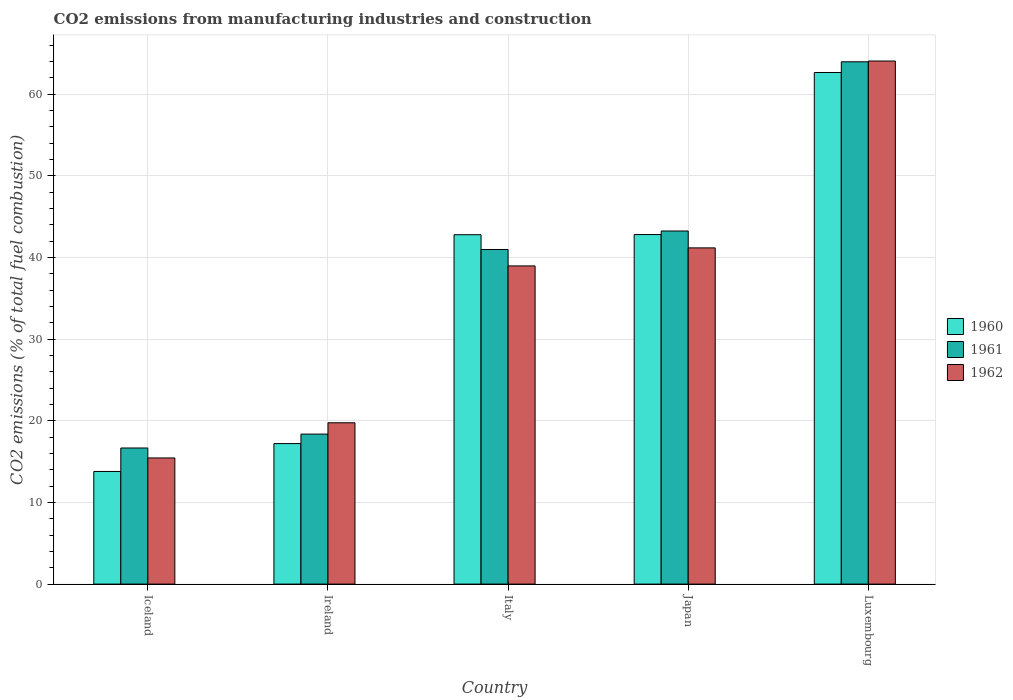How many different coloured bars are there?
Your answer should be very brief. 3. Are the number of bars per tick equal to the number of legend labels?
Give a very brief answer. Yes. How many bars are there on the 5th tick from the left?
Make the answer very short. 3. What is the label of the 4th group of bars from the left?
Offer a terse response. Japan. What is the amount of CO2 emitted in 1961 in Ireland?
Provide a short and direct response. 18.37. Across all countries, what is the maximum amount of CO2 emitted in 1962?
Keep it short and to the point. 64.05. Across all countries, what is the minimum amount of CO2 emitted in 1960?
Provide a succinct answer. 13.79. In which country was the amount of CO2 emitted in 1960 maximum?
Your answer should be compact. Luxembourg. What is the total amount of CO2 emitted in 1960 in the graph?
Make the answer very short. 179.23. What is the difference between the amount of CO2 emitted in 1960 in Iceland and that in Luxembourg?
Provide a short and direct response. -48.85. What is the difference between the amount of CO2 emitted in 1961 in Italy and the amount of CO2 emitted in 1962 in Iceland?
Provide a succinct answer. 25.53. What is the average amount of CO2 emitted in 1962 per country?
Your answer should be very brief. 35.88. What is the difference between the amount of CO2 emitted of/in 1961 and amount of CO2 emitted of/in 1960 in Japan?
Ensure brevity in your answer.  0.44. In how many countries, is the amount of CO2 emitted in 1960 greater than 24 %?
Your answer should be very brief. 3. What is the ratio of the amount of CO2 emitted in 1962 in Ireland to that in Italy?
Make the answer very short. 0.51. Is the difference between the amount of CO2 emitted in 1961 in Iceland and Luxembourg greater than the difference between the amount of CO2 emitted in 1960 in Iceland and Luxembourg?
Ensure brevity in your answer.  Yes. What is the difference between the highest and the second highest amount of CO2 emitted in 1961?
Ensure brevity in your answer.  -2.26. What is the difference between the highest and the lowest amount of CO2 emitted in 1962?
Provide a succinct answer. 48.6. In how many countries, is the amount of CO2 emitted in 1962 greater than the average amount of CO2 emitted in 1962 taken over all countries?
Ensure brevity in your answer.  3. Is the sum of the amount of CO2 emitted in 1962 in Ireland and Japan greater than the maximum amount of CO2 emitted in 1961 across all countries?
Provide a short and direct response. No. What does the 2nd bar from the left in Ireland represents?
Offer a terse response. 1961. What does the 2nd bar from the right in Luxembourg represents?
Provide a succinct answer. 1961. How many bars are there?
Your answer should be compact. 15. What is the difference between two consecutive major ticks on the Y-axis?
Provide a short and direct response. 10. Does the graph contain any zero values?
Ensure brevity in your answer.  No. Does the graph contain grids?
Make the answer very short. Yes. Where does the legend appear in the graph?
Offer a very short reply. Center right. How many legend labels are there?
Offer a very short reply. 3. How are the legend labels stacked?
Give a very brief answer. Vertical. What is the title of the graph?
Offer a terse response. CO2 emissions from manufacturing industries and construction. What is the label or title of the Y-axis?
Offer a terse response. CO2 emissions (% of total fuel combustion). What is the CO2 emissions (% of total fuel combustion) in 1960 in Iceland?
Your response must be concise. 13.79. What is the CO2 emissions (% of total fuel combustion) of 1961 in Iceland?
Your answer should be very brief. 16.67. What is the CO2 emissions (% of total fuel combustion) in 1962 in Iceland?
Your answer should be compact. 15.45. What is the CO2 emissions (% of total fuel combustion) in 1960 in Ireland?
Provide a succinct answer. 17.21. What is the CO2 emissions (% of total fuel combustion) of 1961 in Ireland?
Your answer should be compact. 18.37. What is the CO2 emissions (% of total fuel combustion) of 1962 in Ireland?
Ensure brevity in your answer.  19.75. What is the CO2 emissions (% of total fuel combustion) in 1960 in Italy?
Provide a short and direct response. 42.78. What is the CO2 emissions (% of total fuel combustion) of 1961 in Italy?
Ensure brevity in your answer.  40.97. What is the CO2 emissions (% of total fuel combustion) in 1962 in Italy?
Provide a short and direct response. 38.96. What is the CO2 emissions (% of total fuel combustion) of 1960 in Japan?
Make the answer very short. 42.8. What is the CO2 emissions (% of total fuel combustion) in 1961 in Japan?
Give a very brief answer. 43.24. What is the CO2 emissions (% of total fuel combustion) of 1962 in Japan?
Offer a very short reply. 41.17. What is the CO2 emissions (% of total fuel combustion) in 1960 in Luxembourg?
Give a very brief answer. 62.65. What is the CO2 emissions (% of total fuel combustion) of 1961 in Luxembourg?
Keep it short and to the point. 63.95. What is the CO2 emissions (% of total fuel combustion) in 1962 in Luxembourg?
Ensure brevity in your answer.  64.05. Across all countries, what is the maximum CO2 emissions (% of total fuel combustion) in 1960?
Give a very brief answer. 62.65. Across all countries, what is the maximum CO2 emissions (% of total fuel combustion) of 1961?
Provide a succinct answer. 63.95. Across all countries, what is the maximum CO2 emissions (% of total fuel combustion) of 1962?
Offer a terse response. 64.05. Across all countries, what is the minimum CO2 emissions (% of total fuel combustion) in 1960?
Your answer should be compact. 13.79. Across all countries, what is the minimum CO2 emissions (% of total fuel combustion) in 1961?
Make the answer very short. 16.67. Across all countries, what is the minimum CO2 emissions (% of total fuel combustion) in 1962?
Your answer should be compact. 15.45. What is the total CO2 emissions (% of total fuel combustion) of 1960 in the graph?
Your answer should be compact. 179.23. What is the total CO2 emissions (% of total fuel combustion) of 1961 in the graph?
Keep it short and to the point. 183.2. What is the total CO2 emissions (% of total fuel combustion) in 1962 in the graph?
Your answer should be very brief. 179.38. What is the difference between the CO2 emissions (% of total fuel combustion) in 1960 in Iceland and that in Ireland?
Your response must be concise. -3.41. What is the difference between the CO2 emissions (% of total fuel combustion) of 1961 in Iceland and that in Ireland?
Provide a succinct answer. -1.7. What is the difference between the CO2 emissions (% of total fuel combustion) in 1962 in Iceland and that in Ireland?
Give a very brief answer. -4.31. What is the difference between the CO2 emissions (% of total fuel combustion) in 1960 in Iceland and that in Italy?
Give a very brief answer. -28.99. What is the difference between the CO2 emissions (% of total fuel combustion) in 1961 in Iceland and that in Italy?
Make the answer very short. -24.31. What is the difference between the CO2 emissions (% of total fuel combustion) in 1962 in Iceland and that in Italy?
Provide a short and direct response. -23.51. What is the difference between the CO2 emissions (% of total fuel combustion) of 1960 in Iceland and that in Japan?
Provide a short and direct response. -29.01. What is the difference between the CO2 emissions (% of total fuel combustion) of 1961 in Iceland and that in Japan?
Offer a terse response. -26.57. What is the difference between the CO2 emissions (% of total fuel combustion) of 1962 in Iceland and that in Japan?
Your answer should be compact. -25.72. What is the difference between the CO2 emissions (% of total fuel combustion) in 1960 in Iceland and that in Luxembourg?
Your answer should be compact. -48.85. What is the difference between the CO2 emissions (% of total fuel combustion) of 1961 in Iceland and that in Luxembourg?
Your answer should be compact. -47.29. What is the difference between the CO2 emissions (% of total fuel combustion) of 1962 in Iceland and that in Luxembourg?
Provide a succinct answer. -48.6. What is the difference between the CO2 emissions (% of total fuel combustion) in 1960 in Ireland and that in Italy?
Offer a terse response. -25.57. What is the difference between the CO2 emissions (% of total fuel combustion) of 1961 in Ireland and that in Italy?
Your answer should be compact. -22.61. What is the difference between the CO2 emissions (% of total fuel combustion) of 1962 in Ireland and that in Italy?
Provide a short and direct response. -19.21. What is the difference between the CO2 emissions (% of total fuel combustion) in 1960 in Ireland and that in Japan?
Provide a short and direct response. -25.6. What is the difference between the CO2 emissions (% of total fuel combustion) in 1961 in Ireland and that in Japan?
Provide a short and direct response. -24.87. What is the difference between the CO2 emissions (% of total fuel combustion) of 1962 in Ireland and that in Japan?
Your answer should be very brief. -21.42. What is the difference between the CO2 emissions (% of total fuel combustion) of 1960 in Ireland and that in Luxembourg?
Provide a short and direct response. -45.44. What is the difference between the CO2 emissions (% of total fuel combustion) in 1961 in Ireland and that in Luxembourg?
Provide a short and direct response. -45.59. What is the difference between the CO2 emissions (% of total fuel combustion) of 1962 in Ireland and that in Luxembourg?
Provide a short and direct response. -44.3. What is the difference between the CO2 emissions (% of total fuel combustion) in 1960 in Italy and that in Japan?
Your answer should be very brief. -0.02. What is the difference between the CO2 emissions (% of total fuel combustion) in 1961 in Italy and that in Japan?
Provide a succinct answer. -2.26. What is the difference between the CO2 emissions (% of total fuel combustion) in 1962 in Italy and that in Japan?
Give a very brief answer. -2.21. What is the difference between the CO2 emissions (% of total fuel combustion) of 1960 in Italy and that in Luxembourg?
Provide a succinct answer. -19.86. What is the difference between the CO2 emissions (% of total fuel combustion) in 1961 in Italy and that in Luxembourg?
Ensure brevity in your answer.  -22.98. What is the difference between the CO2 emissions (% of total fuel combustion) in 1962 in Italy and that in Luxembourg?
Offer a terse response. -25.09. What is the difference between the CO2 emissions (% of total fuel combustion) of 1960 in Japan and that in Luxembourg?
Provide a short and direct response. -19.84. What is the difference between the CO2 emissions (% of total fuel combustion) in 1961 in Japan and that in Luxembourg?
Provide a short and direct response. -20.72. What is the difference between the CO2 emissions (% of total fuel combustion) in 1962 in Japan and that in Luxembourg?
Your response must be concise. -22.88. What is the difference between the CO2 emissions (% of total fuel combustion) of 1960 in Iceland and the CO2 emissions (% of total fuel combustion) of 1961 in Ireland?
Make the answer very short. -4.57. What is the difference between the CO2 emissions (% of total fuel combustion) of 1960 in Iceland and the CO2 emissions (% of total fuel combustion) of 1962 in Ireland?
Make the answer very short. -5.96. What is the difference between the CO2 emissions (% of total fuel combustion) in 1961 in Iceland and the CO2 emissions (% of total fuel combustion) in 1962 in Ireland?
Provide a succinct answer. -3.09. What is the difference between the CO2 emissions (% of total fuel combustion) of 1960 in Iceland and the CO2 emissions (% of total fuel combustion) of 1961 in Italy?
Provide a succinct answer. -27.18. What is the difference between the CO2 emissions (% of total fuel combustion) of 1960 in Iceland and the CO2 emissions (% of total fuel combustion) of 1962 in Italy?
Make the answer very short. -25.17. What is the difference between the CO2 emissions (% of total fuel combustion) in 1961 in Iceland and the CO2 emissions (% of total fuel combustion) in 1962 in Italy?
Your answer should be very brief. -22.29. What is the difference between the CO2 emissions (% of total fuel combustion) in 1960 in Iceland and the CO2 emissions (% of total fuel combustion) in 1961 in Japan?
Make the answer very short. -29.44. What is the difference between the CO2 emissions (% of total fuel combustion) of 1960 in Iceland and the CO2 emissions (% of total fuel combustion) of 1962 in Japan?
Provide a succinct answer. -27.38. What is the difference between the CO2 emissions (% of total fuel combustion) of 1961 in Iceland and the CO2 emissions (% of total fuel combustion) of 1962 in Japan?
Make the answer very short. -24.5. What is the difference between the CO2 emissions (% of total fuel combustion) in 1960 in Iceland and the CO2 emissions (% of total fuel combustion) in 1961 in Luxembourg?
Offer a very short reply. -50.16. What is the difference between the CO2 emissions (% of total fuel combustion) in 1960 in Iceland and the CO2 emissions (% of total fuel combustion) in 1962 in Luxembourg?
Your response must be concise. -50.26. What is the difference between the CO2 emissions (% of total fuel combustion) of 1961 in Iceland and the CO2 emissions (% of total fuel combustion) of 1962 in Luxembourg?
Make the answer very short. -47.38. What is the difference between the CO2 emissions (% of total fuel combustion) of 1960 in Ireland and the CO2 emissions (% of total fuel combustion) of 1961 in Italy?
Offer a very short reply. -23.77. What is the difference between the CO2 emissions (% of total fuel combustion) of 1960 in Ireland and the CO2 emissions (% of total fuel combustion) of 1962 in Italy?
Your answer should be compact. -21.75. What is the difference between the CO2 emissions (% of total fuel combustion) in 1961 in Ireland and the CO2 emissions (% of total fuel combustion) in 1962 in Italy?
Provide a short and direct response. -20.59. What is the difference between the CO2 emissions (% of total fuel combustion) of 1960 in Ireland and the CO2 emissions (% of total fuel combustion) of 1961 in Japan?
Ensure brevity in your answer.  -26.03. What is the difference between the CO2 emissions (% of total fuel combustion) in 1960 in Ireland and the CO2 emissions (% of total fuel combustion) in 1962 in Japan?
Offer a very short reply. -23.96. What is the difference between the CO2 emissions (% of total fuel combustion) of 1961 in Ireland and the CO2 emissions (% of total fuel combustion) of 1962 in Japan?
Provide a short and direct response. -22.8. What is the difference between the CO2 emissions (% of total fuel combustion) of 1960 in Ireland and the CO2 emissions (% of total fuel combustion) of 1961 in Luxembourg?
Ensure brevity in your answer.  -46.75. What is the difference between the CO2 emissions (% of total fuel combustion) of 1960 in Ireland and the CO2 emissions (% of total fuel combustion) of 1962 in Luxembourg?
Ensure brevity in your answer.  -46.84. What is the difference between the CO2 emissions (% of total fuel combustion) in 1961 in Ireland and the CO2 emissions (% of total fuel combustion) in 1962 in Luxembourg?
Keep it short and to the point. -45.68. What is the difference between the CO2 emissions (% of total fuel combustion) in 1960 in Italy and the CO2 emissions (% of total fuel combustion) in 1961 in Japan?
Keep it short and to the point. -0.46. What is the difference between the CO2 emissions (% of total fuel combustion) of 1960 in Italy and the CO2 emissions (% of total fuel combustion) of 1962 in Japan?
Your answer should be compact. 1.61. What is the difference between the CO2 emissions (% of total fuel combustion) of 1961 in Italy and the CO2 emissions (% of total fuel combustion) of 1962 in Japan?
Ensure brevity in your answer.  -0.2. What is the difference between the CO2 emissions (% of total fuel combustion) of 1960 in Italy and the CO2 emissions (% of total fuel combustion) of 1961 in Luxembourg?
Offer a very short reply. -21.17. What is the difference between the CO2 emissions (% of total fuel combustion) in 1960 in Italy and the CO2 emissions (% of total fuel combustion) in 1962 in Luxembourg?
Offer a terse response. -21.27. What is the difference between the CO2 emissions (% of total fuel combustion) of 1961 in Italy and the CO2 emissions (% of total fuel combustion) of 1962 in Luxembourg?
Your answer should be compact. -23.08. What is the difference between the CO2 emissions (% of total fuel combustion) in 1960 in Japan and the CO2 emissions (% of total fuel combustion) in 1961 in Luxembourg?
Offer a terse response. -21.15. What is the difference between the CO2 emissions (% of total fuel combustion) of 1960 in Japan and the CO2 emissions (% of total fuel combustion) of 1962 in Luxembourg?
Offer a very short reply. -21.25. What is the difference between the CO2 emissions (% of total fuel combustion) in 1961 in Japan and the CO2 emissions (% of total fuel combustion) in 1962 in Luxembourg?
Your response must be concise. -20.81. What is the average CO2 emissions (% of total fuel combustion) of 1960 per country?
Give a very brief answer. 35.85. What is the average CO2 emissions (% of total fuel combustion) in 1961 per country?
Keep it short and to the point. 36.64. What is the average CO2 emissions (% of total fuel combustion) of 1962 per country?
Give a very brief answer. 35.88. What is the difference between the CO2 emissions (% of total fuel combustion) in 1960 and CO2 emissions (% of total fuel combustion) in 1961 in Iceland?
Offer a very short reply. -2.87. What is the difference between the CO2 emissions (% of total fuel combustion) in 1960 and CO2 emissions (% of total fuel combustion) in 1962 in Iceland?
Make the answer very short. -1.65. What is the difference between the CO2 emissions (% of total fuel combustion) in 1961 and CO2 emissions (% of total fuel combustion) in 1962 in Iceland?
Your response must be concise. 1.22. What is the difference between the CO2 emissions (% of total fuel combustion) of 1960 and CO2 emissions (% of total fuel combustion) of 1961 in Ireland?
Offer a very short reply. -1.16. What is the difference between the CO2 emissions (% of total fuel combustion) in 1960 and CO2 emissions (% of total fuel combustion) in 1962 in Ireland?
Provide a succinct answer. -2.55. What is the difference between the CO2 emissions (% of total fuel combustion) in 1961 and CO2 emissions (% of total fuel combustion) in 1962 in Ireland?
Your answer should be very brief. -1.39. What is the difference between the CO2 emissions (% of total fuel combustion) in 1960 and CO2 emissions (% of total fuel combustion) in 1961 in Italy?
Give a very brief answer. 1.81. What is the difference between the CO2 emissions (% of total fuel combustion) of 1960 and CO2 emissions (% of total fuel combustion) of 1962 in Italy?
Give a very brief answer. 3.82. What is the difference between the CO2 emissions (% of total fuel combustion) in 1961 and CO2 emissions (% of total fuel combustion) in 1962 in Italy?
Your response must be concise. 2.01. What is the difference between the CO2 emissions (% of total fuel combustion) in 1960 and CO2 emissions (% of total fuel combustion) in 1961 in Japan?
Keep it short and to the point. -0.44. What is the difference between the CO2 emissions (% of total fuel combustion) of 1960 and CO2 emissions (% of total fuel combustion) of 1962 in Japan?
Your answer should be very brief. 1.63. What is the difference between the CO2 emissions (% of total fuel combustion) of 1961 and CO2 emissions (% of total fuel combustion) of 1962 in Japan?
Your answer should be very brief. 2.07. What is the difference between the CO2 emissions (% of total fuel combustion) in 1960 and CO2 emissions (% of total fuel combustion) in 1961 in Luxembourg?
Provide a succinct answer. -1.31. What is the difference between the CO2 emissions (% of total fuel combustion) in 1960 and CO2 emissions (% of total fuel combustion) in 1962 in Luxembourg?
Make the answer very short. -1.4. What is the difference between the CO2 emissions (% of total fuel combustion) in 1961 and CO2 emissions (% of total fuel combustion) in 1962 in Luxembourg?
Ensure brevity in your answer.  -0.1. What is the ratio of the CO2 emissions (% of total fuel combustion) in 1960 in Iceland to that in Ireland?
Offer a very short reply. 0.8. What is the ratio of the CO2 emissions (% of total fuel combustion) of 1961 in Iceland to that in Ireland?
Give a very brief answer. 0.91. What is the ratio of the CO2 emissions (% of total fuel combustion) in 1962 in Iceland to that in Ireland?
Your answer should be compact. 0.78. What is the ratio of the CO2 emissions (% of total fuel combustion) in 1960 in Iceland to that in Italy?
Offer a terse response. 0.32. What is the ratio of the CO2 emissions (% of total fuel combustion) of 1961 in Iceland to that in Italy?
Provide a succinct answer. 0.41. What is the ratio of the CO2 emissions (% of total fuel combustion) in 1962 in Iceland to that in Italy?
Give a very brief answer. 0.4. What is the ratio of the CO2 emissions (% of total fuel combustion) of 1960 in Iceland to that in Japan?
Offer a very short reply. 0.32. What is the ratio of the CO2 emissions (% of total fuel combustion) in 1961 in Iceland to that in Japan?
Keep it short and to the point. 0.39. What is the ratio of the CO2 emissions (% of total fuel combustion) in 1962 in Iceland to that in Japan?
Ensure brevity in your answer.  0.38. What is the ratio of the CO2 emissions (% of total fuel combustion) of 1960 in Iceland to that in Luxembourg?
Keep it short and to the point. 0.22. What is the ratio of the CO2 emissions (% of total fuel combustion) in 1961 in Iceland to that in Luxembourg?
Keep it short and to the point. 0.26. What is the ratio of the CO2 emissions (% of total fuel combustion) of 1962 in Iceland to that in Luxembourg?
Ensure brevity in your answer.  0.24. What is the ratio of the CO2 emissions (% of total fuel combustion) in 1960 in Ireland to that in Italy?
Your answer should be very brief. 0.4. What is the ratio of the CO2 emissions (% of total fuel combustion) of 1961 in Ireland to that in Italy?
Make the answer very short. 0.45. What is the ratio of the CO2 emissions (% of total fuel combustion) of 1962 in Ireland to that in Italy?
Provide a short and direct response. 0.51. What is the ratio of the CO2 emissions (% of total fuel combustion) in 1960 in Ireland to that in Japan?
Your answer should be very brief. 0.4. What is the ratio of the CO2 emissions (% of total fuel combustion) of 1961 in Ireland to that in Japan?
Give a very brief answer. 0.42. What is the ratio of the CO2 emissions (% of total fuel combustion) of 1962 in Ireland to that in Japan?
Ensure brevity in your answer.  0.48. What is the ratio of the CO2 emissions (% of total fuel combustion) in 1960 in Ireland to that in Luxembourg?
Your response must be concise. 0.27. What is the ratio of the CO2 emissions (% of total fuel combustion) in 1961 in Ireland to that in Luxembourg?
Your response must be concise. 0.29. What is the ratio of the CO2 emissions (% of total fuel combustion) in 1962 in Ireland to that in Luxembourg?
Your answer should be very brief. 0.31. What is the ratio of the CO2 emissions (% of total fuel combustion) in 1960 in Italy to that in Japan?
Provide a short and direct response. 1. What is the ratio of the CO2 emissions (% of total fuel combustion) of 1961 in Italy to that in Japan?
Your response must be concise. 0.95. What is the ratio of the CO2 emissions (% of total fuel combustion) in 1962 in Italy to that in Japan?
Offer a very short reply. 0.95. What is the ratio of the CO2 emissions (% of total fuel combustion) of 1960 in Italy to that in Luxembourg?
Your response must be concise. 0.68. What is the ratio of the CO2 emissions (% of total fuel combustion) of 1961 in Italy to that in Luxembourg?
Offer a terse response. 0.64. What is the ratio of the CO2 emissions (% of total fuel combustion) in 1962 in Italy to that in Luxembourg?
Your answer should be compact. 0.61. What is the ratio of the CO2 emissions (% of total fuel combustion) of 1960 in Japan to that in Luxembourg?
Offer a very short reply. 0.68. What is the ratio of the CO2 emissions (% of total fuel combustion) of 1961 in Japan to that in Luxembourg?
Ensure brevity in your answer.  0.68. What is the ratio of the CO2 emissions (% of total fuel combustion) in 1962 in Japan to that in Luxembourg?
Your answer should be compact. 0.64. What is the difference between the highest and the second highest CO2 emissions (% of total fuel combustion) in 1960?
Provide a short and direct response. 19.84. What is the difference between the highest and the second highest CO2 emissions (% of total fuel combustion) in 1961?
Your answer should be compact. 20.72. What is the difference between the highest and the second highest CO2 emissions (% of total fuel combustion) of 1962?
Offer a terse response. 22.88. What is the difference between the highest and the lowest CO2 emissions (% of total fuel combustion) of 1960?
Provide a short and direct response. 48.85. What is the difference between the highest and the lowest CO2 emissions (% of total fuel combustion) of 1961?
Your answer should be very brief. 47.29. What is the difference between the highest and the lowest CO2 emissions (% of total fuel combustion) of 1962?
Your response must be concise. 48.6. 